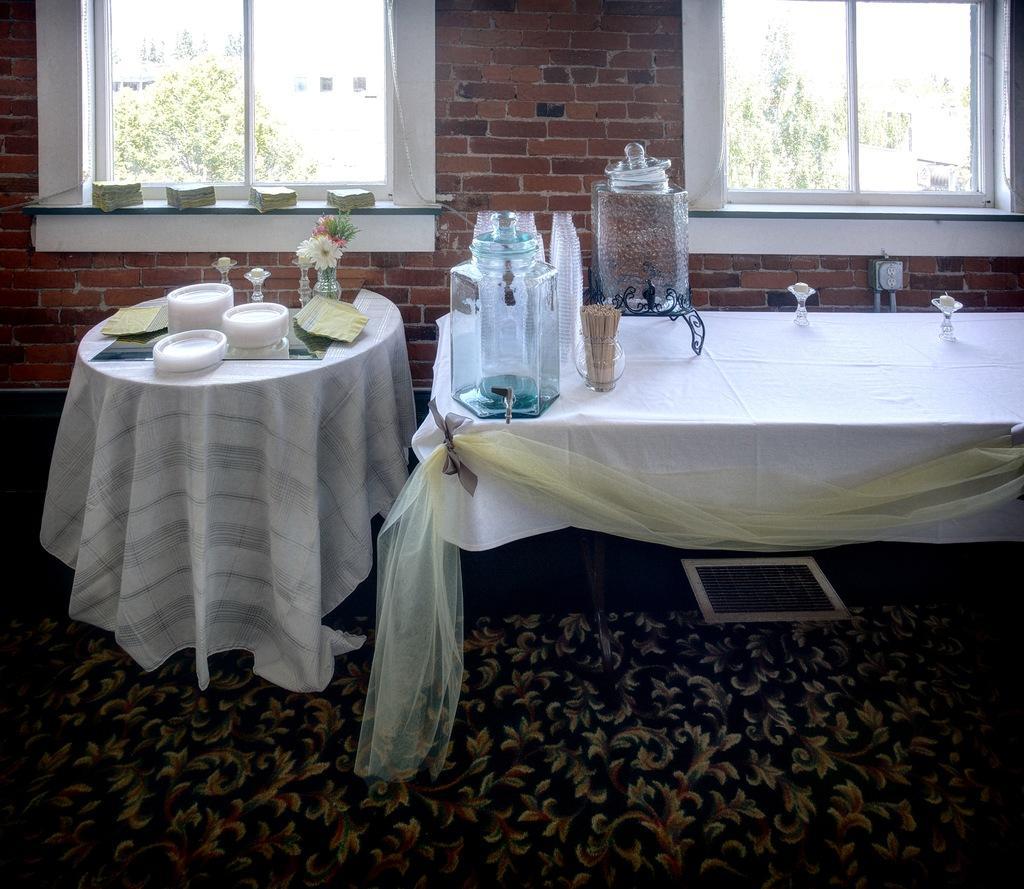Describe this image in one or two sentences. In the picture we can see two tables with a table cloth on it and on it we can see some plates and flower vase with flowers and on the other table we can see some jars and behind it we can see a wall with windows and glasses to it and from it we can see some plants and on the floor we can see floor mat with some designs on it. 